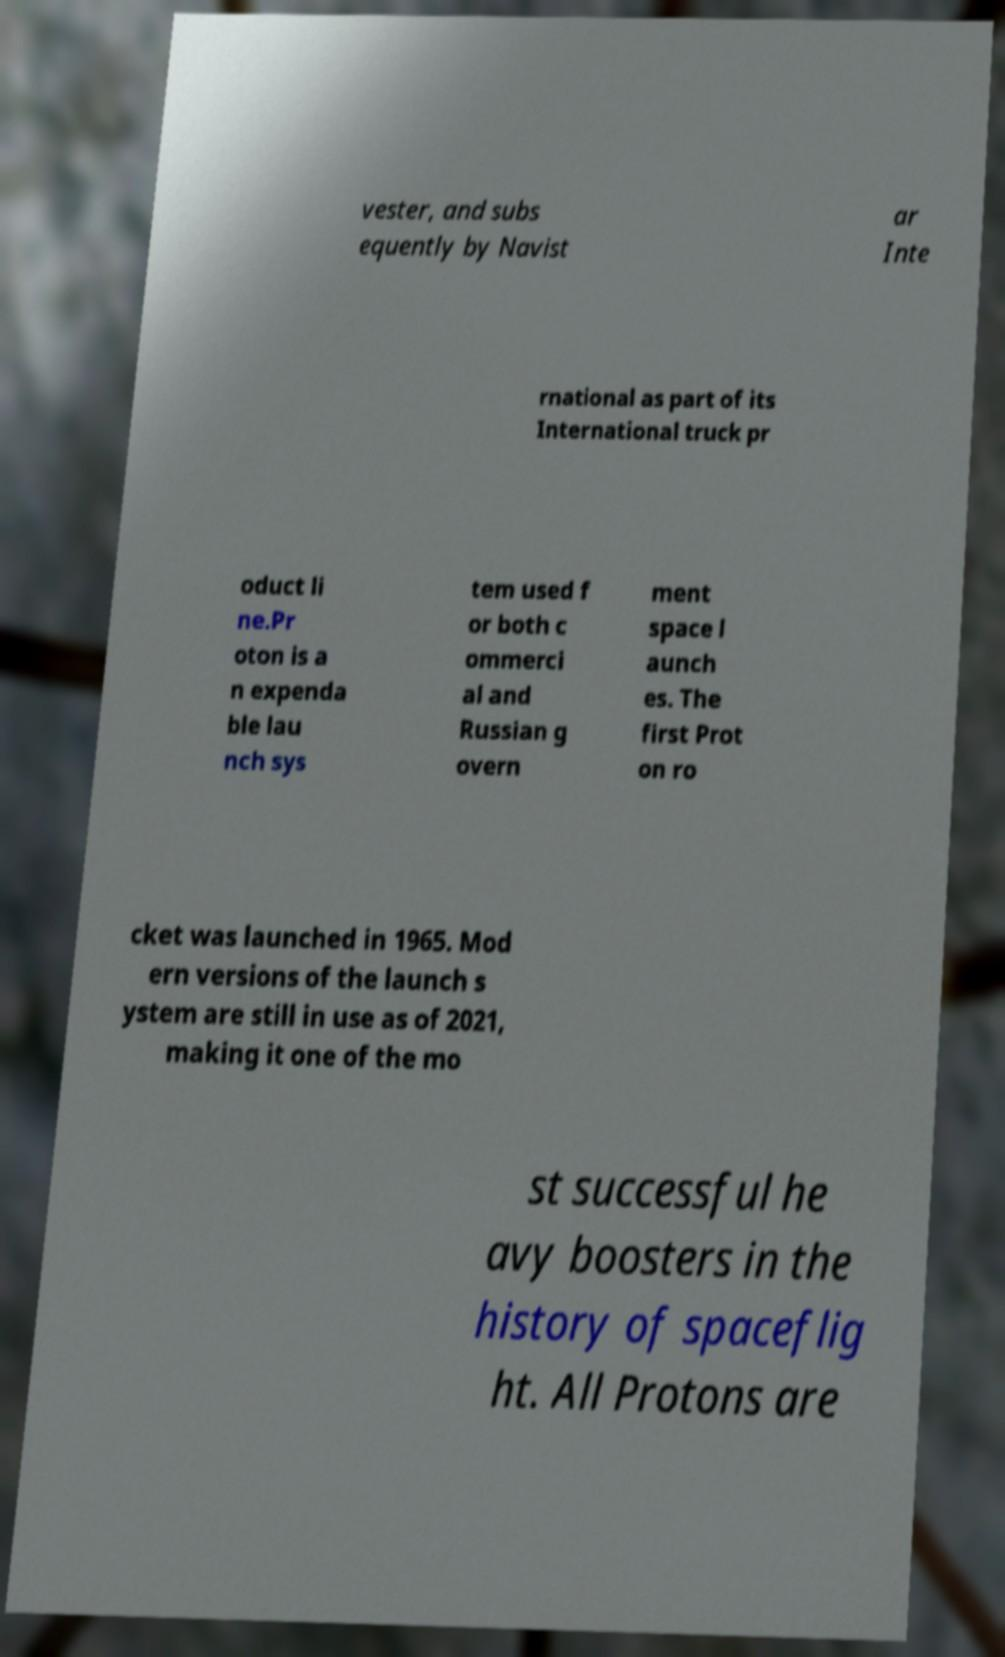What messages or text are displayed in this image? I need them in a readable, typed format. vester, and subs equently by Navist ar Inte rnational as part of its International truck pr oduct li ne.Pr oton is a n expenda ble lau nch sys tem used f or both c ommerci al and Russian g overn ment space l aunch es. The first Prot on ro cket was launched in 1965. Mod ern versions of the launch s ystem are still in use as of 2021, making it one of the mo st successful he avy boosters in the history of spaceflig ht. All Protons are 